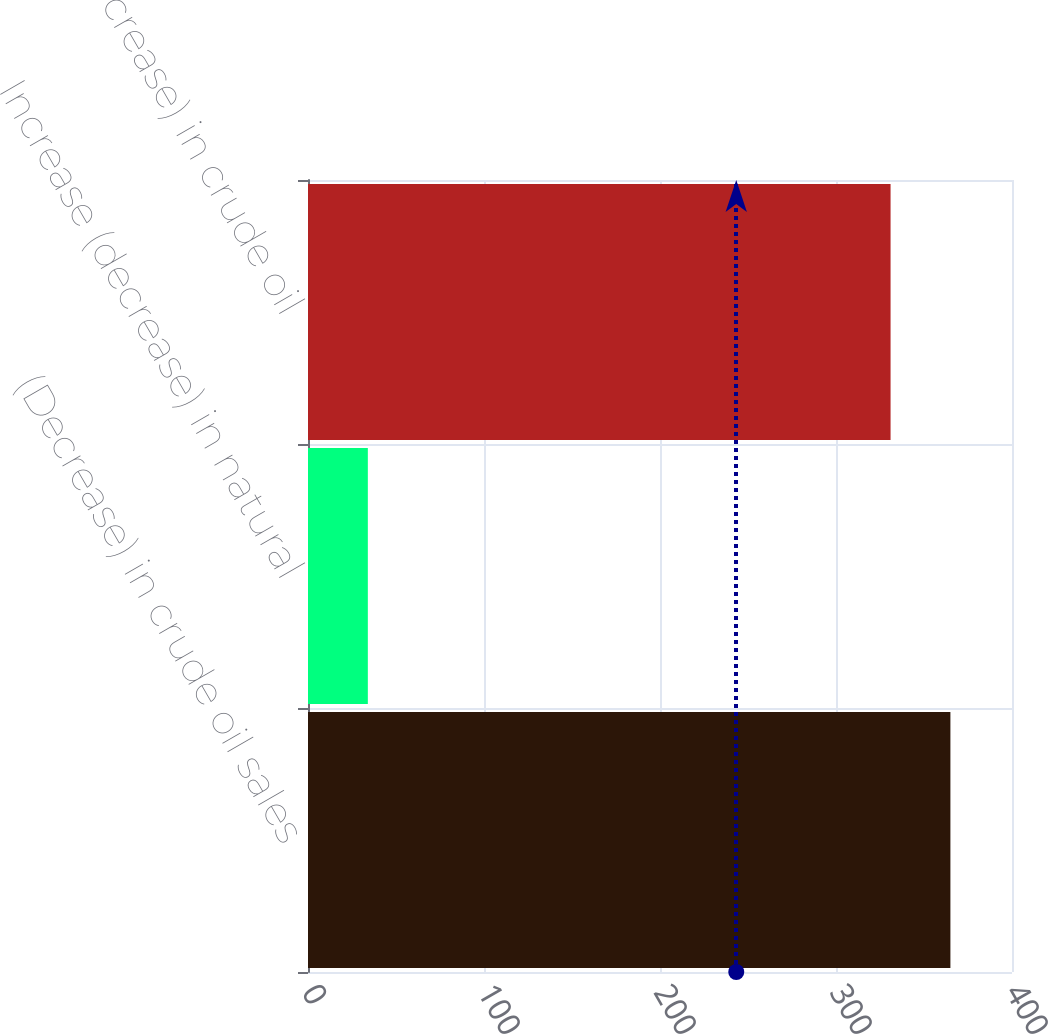Convert chart. <chart><loc_0><loc_0><loc_500><loc_500><bar_chart><fcel>(Decrease) in crude oil sales<fcel>Increase (decrease) in natural<fcel>Total (decrease) in crude oil<nl><fcel>365<fcel>34<fcel>331<nl></chart> 